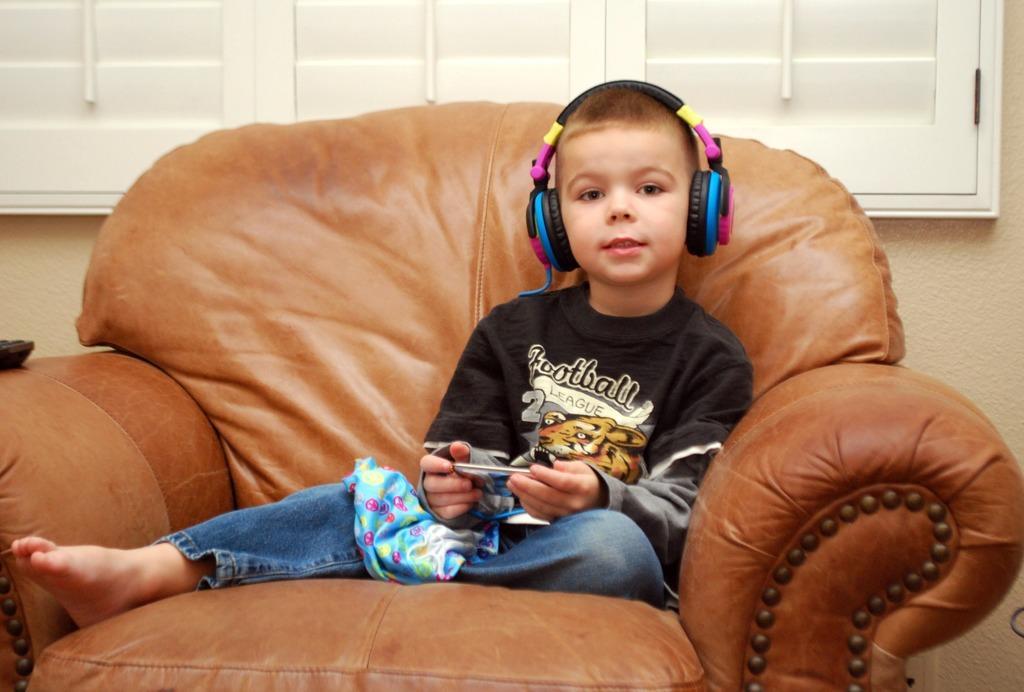Can you describe this image briefly? In this image, we can see a boy wearing headphones and holding an object. He is sitting on a chair. In the background, we can see wall and window blinds. On the left side of the image, we can see black color object hand rest of a chair. 